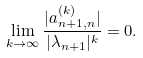<formula> <loc_0><loc_0><loc_500><loc_500>\lim _ { k \to \infty } \frac { | a ^ { ( k ) } _ { n + 1 , n } | } { | \lambda _ { n + 1 } | ^ { k } } = 0 .</formula> 